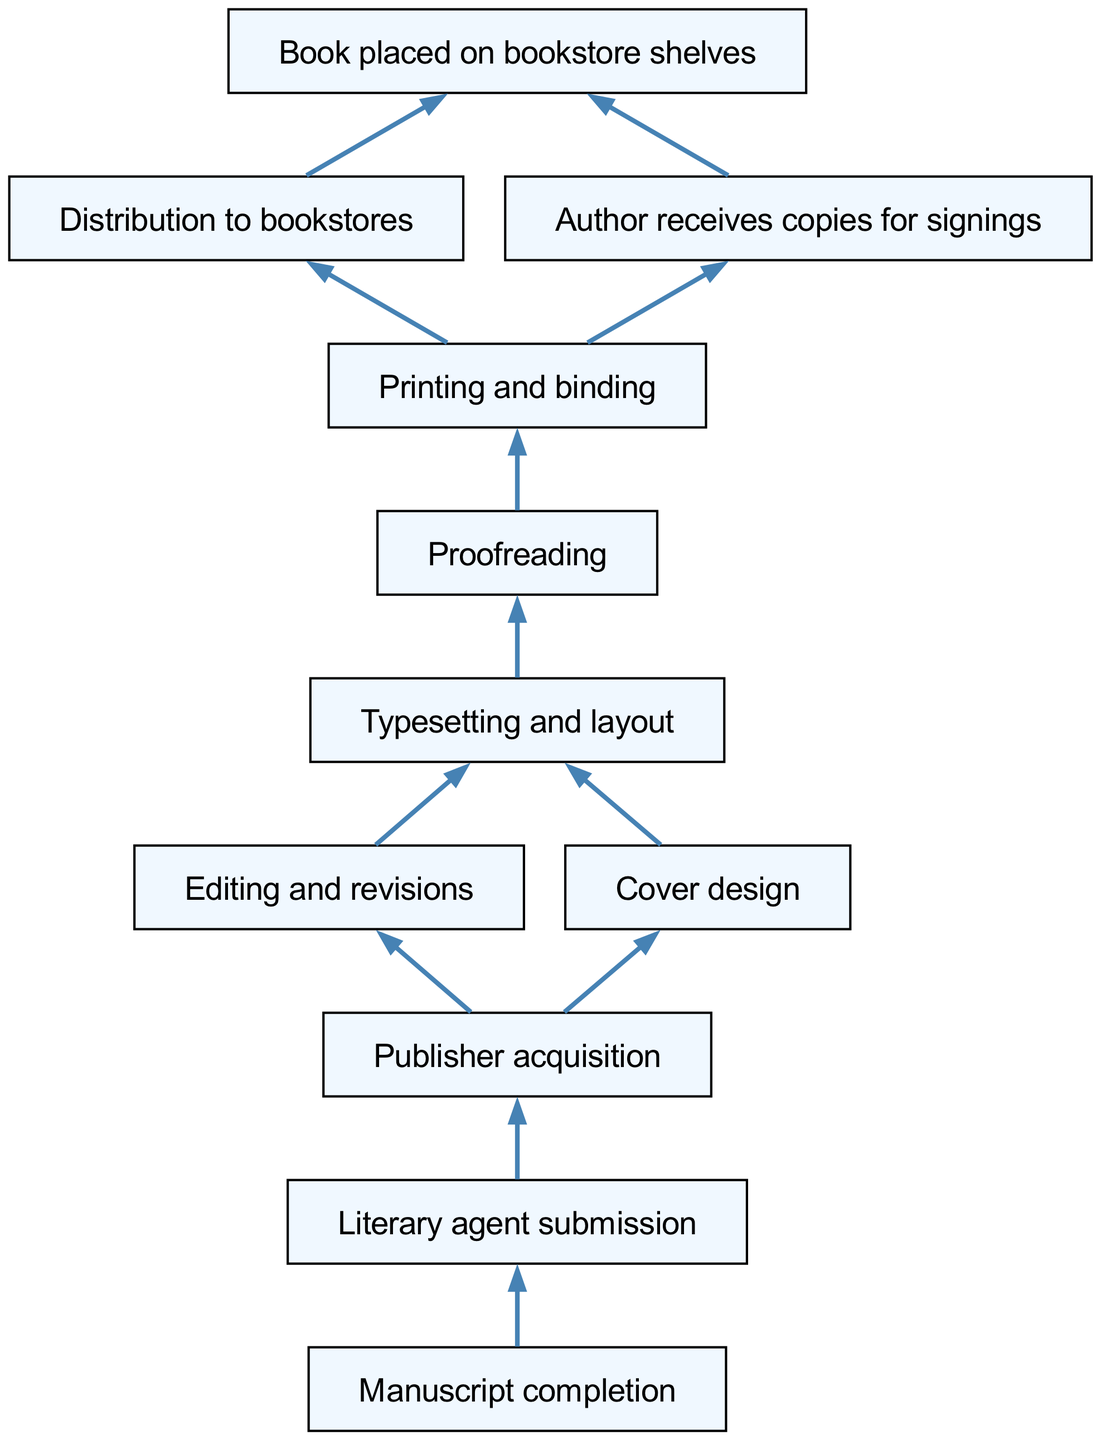What is the first step in the book publishing process? The diagram starts with the node labeled "Manuscript completion," indicating that this is the first step in the process.
Answer: Manuscript completion How many nodes are there in the diagram? By counting all the elements in the provided data, there are 11 unique nodes, each representing a specific step in the publishing process.
Answer: 11 What is the relationship between editing and revisions and typesetting and layout? In the diagram, "Editing and revisions" points to "Typesetting and layout," indicating that typesetting occurs after editing.
Answer: Typesetting and layout What step comes after proofreading? The arrow from "Proofreading" leads to "Printing and binding," showing that this step follows proofreading in the process.
Answer: Printing and binding Which two steps occur simultaneously before typesetting? The diagram shows that both "Editing and revisions" and "Cover design" have edges leading to "Typesetting and layout," indicating they happen at the same time.
Answer: Editing and revisions and Cover design What happens after "Distribution to bookstores"? The "Distribution to bookstores" node connects to "Book placed on bookstore shelves," meaning the next step after distribution is placement on shelves.
Answer: Book placed on bookstore shelves How many final steps are there after printing and binding? Following "Printing and binding," two primary steps branch out: "Distribution to bookstores" and "Author receives copies for signings," so there are two final steps.
Answer: 2 Which step does the author receive copies for? The connection between "Author receives copies for signings" and "Printing and binding" indicates that the author receives copies after printing and binding.
Answer: Printing and binding What connects literary agent submission to publisher acquisition? The arrow from "Literary agent submission" directly leads to "Publisher acquisition," indicating that the submission leads to the next step of acquiring a publisher.
Answer: Publisher acquisition 